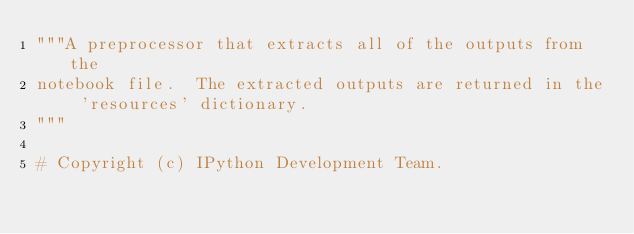<code> <loc_0><loc_0><loc_500><loc_500><_Python_>"""A preprocessor that extracts all of the outputs from the
notebook file.  The extracted outputs are returned in the 'resources' dictionary.
"""

# Copyright (c) IPython Development Team.</code> 